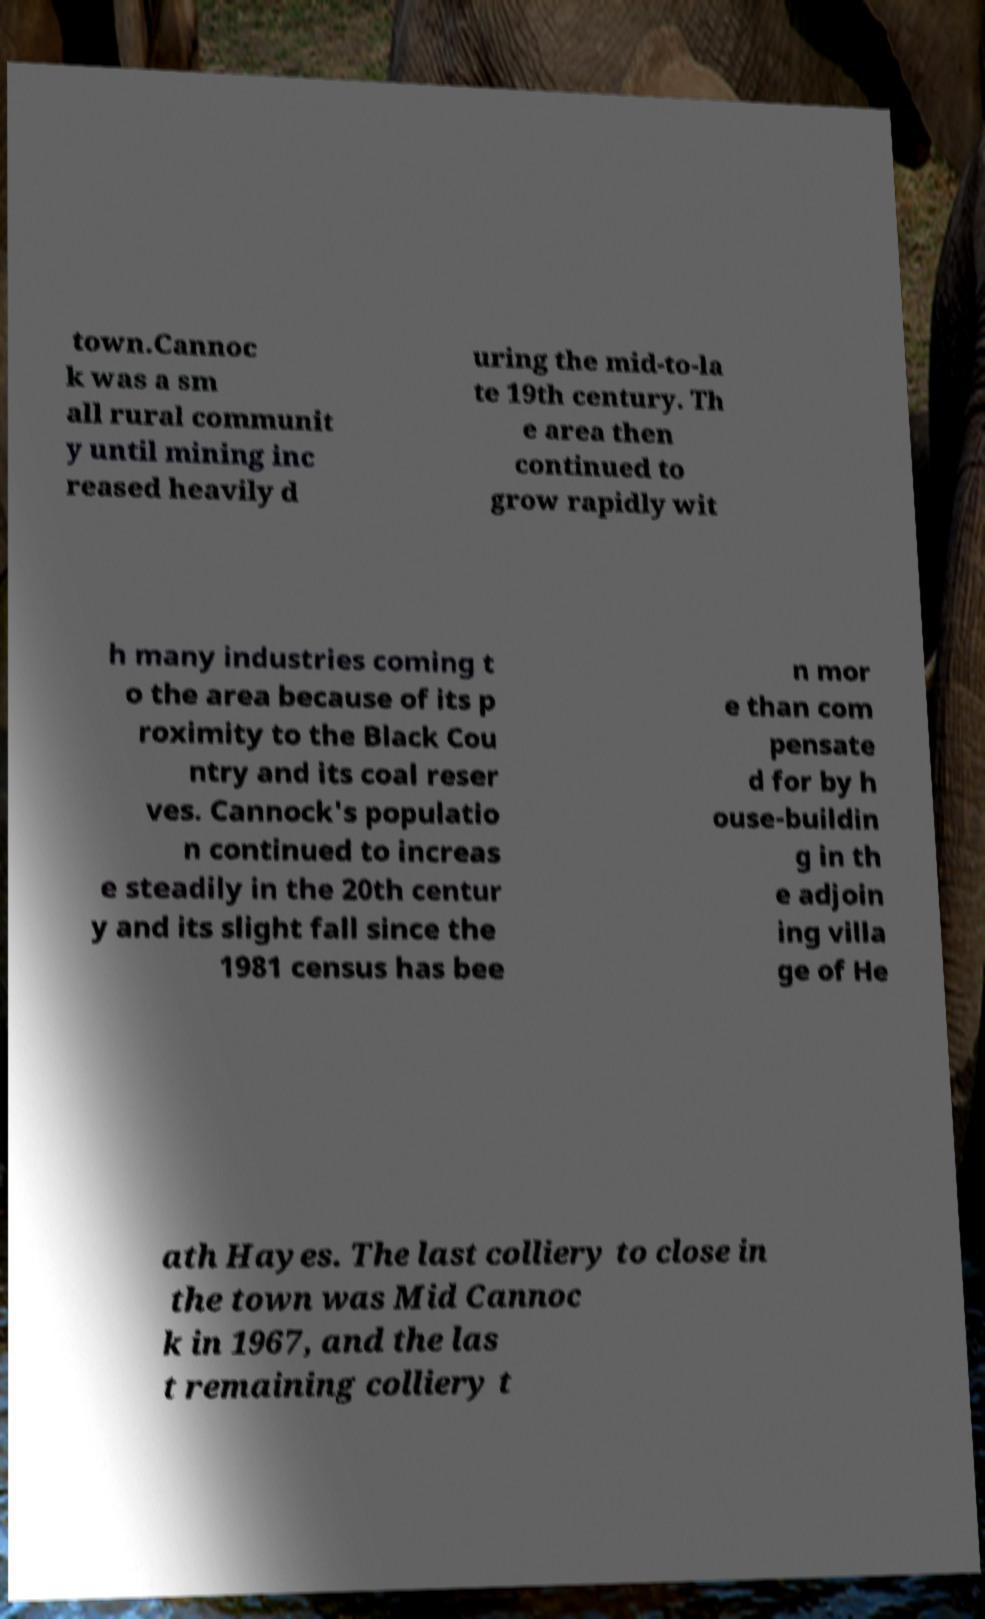Can you read and provide the text displayed in the image?This photo seems to have some interesting text. Can you extract and type it out for me? town.Cannoc k was a sm all rural communit y until mining inc reased heavily d uring the mid-to-la te 19th century. Th e area then continued to grow rapidly wit h many industries coming t o the area because of its p roximity to the Black Cou ntry and its coal reser ves. Cannock's populatio n continued to increas e steadily in the 20th centur y and its slight fall since the 1981 census has bee n mor e than com pensate d for by h ouse-buildin g in th e adjoin ing villa ge of He ath Hayes. The last colliery to close in the town was Mid Cannoc k in 1967, and the las t remaining colliery t 